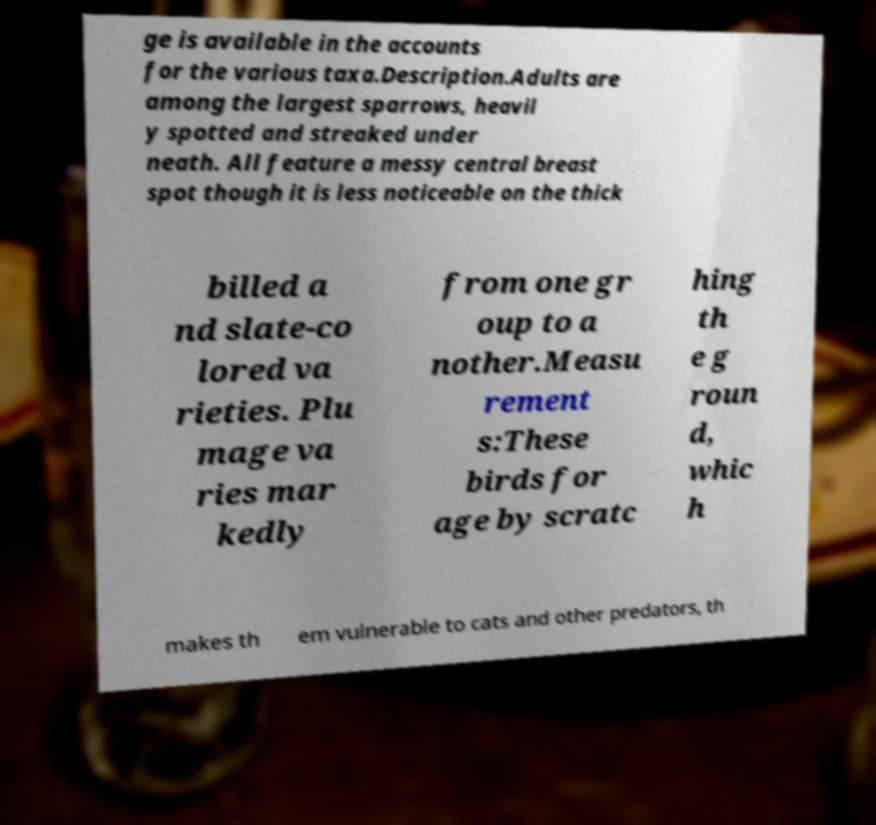Please identify and transcribe the text found in this image. ge is available in the accounts for the various taxa.Description.Adults are among the largest sparrows, heavil y spotted and streaked under neath. All feature a messy central breast spot though it is less noticeable on the thick billed a nd slate-co lored va rieties. Plu mage va ries mar kedly from one gr oup to a nother.Measu rement s:These birds for age by scratc hing th e g roun d, whic h makes th em vulnerable to cats and other predators, th 